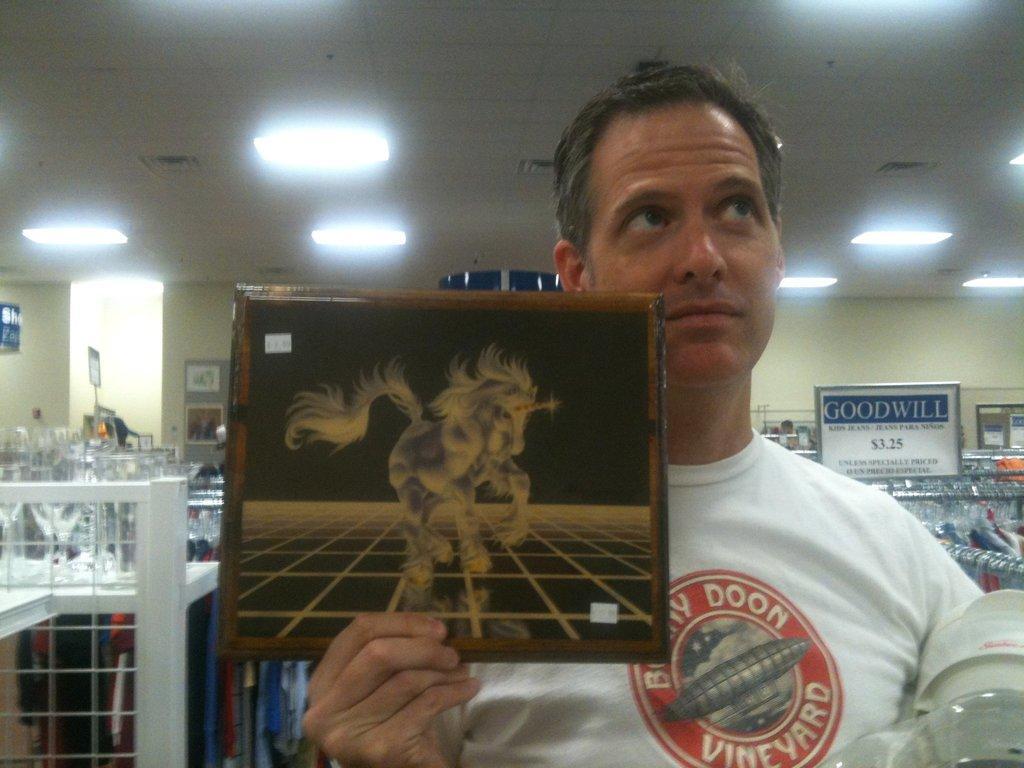What is the person in the image holding? The person is holding a board in the image. What can be seen in the background of the image? There are tables visible in the background of the image. What is placed on the tables? There are objects placed on the tables. What type of paper can be seen on the bedroom floor in the image? There is no paper or bedroom present in the image; it features a person holding a board and tables in the background. 